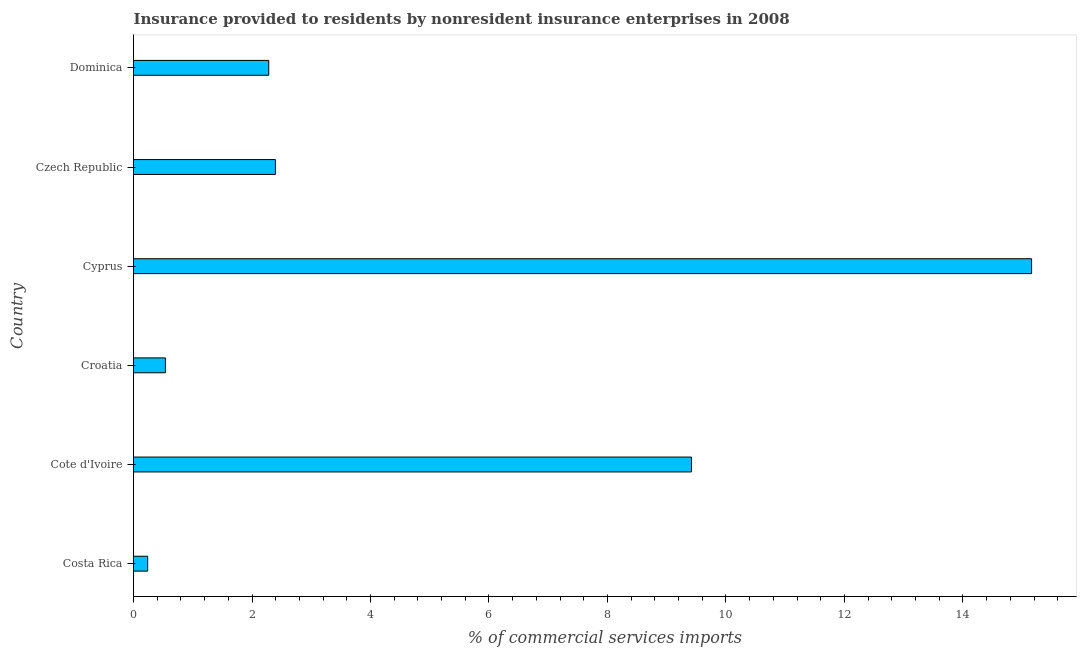Does the graph contain any zero values?
Your answer should be compact. No. Does the graph contain grids?
Give a very brief answer. No. What is the title of the graph?
Keep it short and to the point. Insurance provided to residents by nonresident insurance enterprises in 2008. What is the label or title of the X-axis?
Offer a terse response. % of commercial services imports. What is the label or title of the Y-axis?
Make the answer very short. Country. What is the insurance provided by non-residents in Costa Rica?
Offer a very short reply. 0.24. Across all countries, what is the maximum insurance provided by non-residents?
Offer a very short reply. 15.16. Across all countries, what is the minimum insurance provided by non-residents?
Give a very brief answer. 0.24. In which country was the insurance provided by non-residents maximum?
Provide a succinct answer. Cyprus. In which country was the insurance provided by non-residents minimum?
Keep it short and to the point. Costa Rica. What is the sum of the insurance provided by non-residents?
Make the answer very short. 30.03. What is the difference between the insurance provided by non-residents in Costa Rica and Dominica?
Ensure brevity in your answer.  -2.04. What is the average insurance provided by non-residents per country?
Your answer should be very brief. 5. What is the median insurance provided by non-residents?
Your response must be concise. 2.34. What is the ratio of the insurance provided by non-residents in Cote d'Ivoire to that in Dominica?
Offer a terse response. 4.12. What is the difference between the highest and the second highest insurance provided by non-residents?
Provide a short and direct response. 5.74. What is the difference between the highest and the lowest insurance provided by non-residents?
Provide a short and direct response. 14.92. How many bars are there?
Offer a terse response. 6. Are all the bars in the graph horizontal?
Ensure brevity in your answer.  Yes. How many countries are there in the graph?
Your response must be concise. 6. What is the % of commercial services imports of Costa Rica?
Your answer should be very brief. 0.24. What is the % of commercial services imports in Cote d'Ivoire?
Your response must be concise. 9.42. What is the % of commercial services imports in Croatia?
Offer a terse response. 0.54. What is the % of commercial services imports of Cyprus?
Your answer should be compact. 15.16. What is the % of commercial services imports in Czech Republic?
Make the answer very short. 2.4. What is the % of commercial services imports of Dominica?
Make the answer very short. 2.28. What is the difference between the % of commercial services imports in Costa Rica and Cote d'Ivoire?
Give a very brief answer. -9.18. What is the difference between the % of commercial services imports in Costa Rica and Croatia?
Offer a terse response. -0.3. What is the difference between the % of commercial services imports in Costa Rica and Cyprus?
Provide a succinct answer. -14.92. What is the difference between the % of commercial services imports in Costa Rica and Czech Republic?
Provide a succinct answer. -2.16. What is the difference between the % of commercial services imports in Costa Rica and Dominica?
Offer a terse response. -2.04. What is the difference between the % of commercial services imports in Cote d'Ivoire and Croatia?
Offer a terse response. 8.88. What is the difference between the % of commercial services imports in Cote d'Ivoire and Cyprus?
Keep it short and to the point. -5.74. What is the difference between the % of commercial services imports in Cote d'Ivoire and Czech Republic?
Provide a short and direct response. 7.02. What is the difference between the % of commercial services imports in Cote d'Ivoire and Dominica?
Give a very brief answer. 7.13. What is the difference between the % of commercial services imports in Croatia and Cyprus?
Ensure brevity in your answer.  -14.62. What is the difference between the % of commercial services imports in Croatia and Czech Republic?
Your answer should be compact. -1.86. What is the difference between the % of commercial services imports in Croatia and Dominica?
Offer a very short reply. -1.74. What is the difference between the % of commercial services imports in Cyprus and Czech Republic?
Offer a terse response. 12.76. What is the difference between the % of commercial services imports in Cyprus and Dominica?
Give a very brief answer. 12.88. What is the difference between the % of commercial services imports in Czech Republic and Dominica?
Your response must be concise. 0.11. What is the ratio of the % of commercial services imports in Costa Rica to that in Cote d'Ivoire?
Your answer should be compact. 0.03. What is the ratio of the % of commercial services imports in Costa Rica to that in Croatia?
Provide a short and direct response. 0.44. What is the ratio of the % of commercial services imports in Costa Rica to that in Cyprus?
Provide a short and direct response. 0.02. What is the ratio of the % of commercial services imports in Costa Rica to that in Dominica?
Your answer should be very brief. 0.1. What is the ratio of the % of commercial services imports in Cote d'Ivoire to that in Croatia?
Your answer should be very brief. 17.5. What is the ratio of the % of commercial services imports in Cote d'Ivoire to that in Cyprus?
Your response must be concise. 0.62. What is the ratio of the % of commercial services imports in Cote d'Ivoire to that in Czech Republic?
Your answer should be compact. 3.93. What is the ratio of the % of commercial services imports in Cote d'Ivoire to that in Dominica?
Your response must be concise. 4.12. What is the ratio of the % of commercial services imports in Croatia to that in Cyprus?
Your response must be concise. 0.04. What is the ratio of the % of commercial services imports in Croatia to that in Czech Republic?
Keep it short and to the point. 0.23. What is the ratio of the % of commercial services imports in Croatia to that in Dominica?
Your answer should be compact. 0.24. What is the ratio of the % of commercial services imports in Cyprus to that in Czech Republic?
Offer a very short reply. 6.33. What is the ratio of the % of commercial services imports in Cyprus to that in Dominica?
Provide a succinct answer. 6.64. What is the ratio of the % of commercial services imports in Czech Republic to that in Dominica?
Make the answer very short. 1.05. 